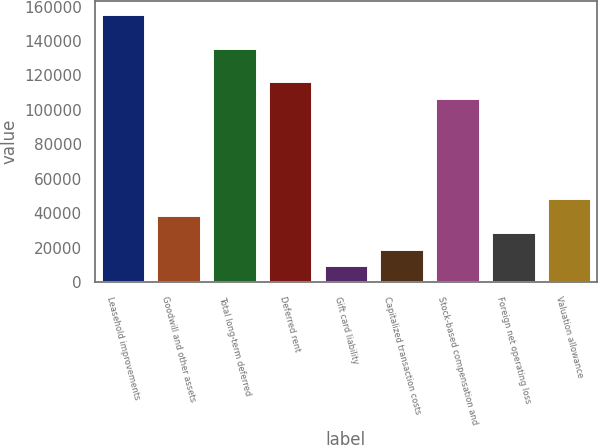Convert chart. <chart><loc_0><loc_0><loc_500><loc_500><bar_chart><fcel>Leasehold improvements<fcel>Goodwill and other assets<fcel>Total long-term deferred<fcel>Deferred rent<fcel>Gift card liability<fcel>Capitalized transaction costs<fcel>Stock-based compensation and<fcel>Foreign net operating loss<fcel>Valuation allowance<nl><fcel>155515<fcel>38912.6<fcel>136082<fcel>116648<fcel>9761.9<fcel>19478.8<fcel>106931<fcel>29195.7<fcel>48629.5<nl></chart> 